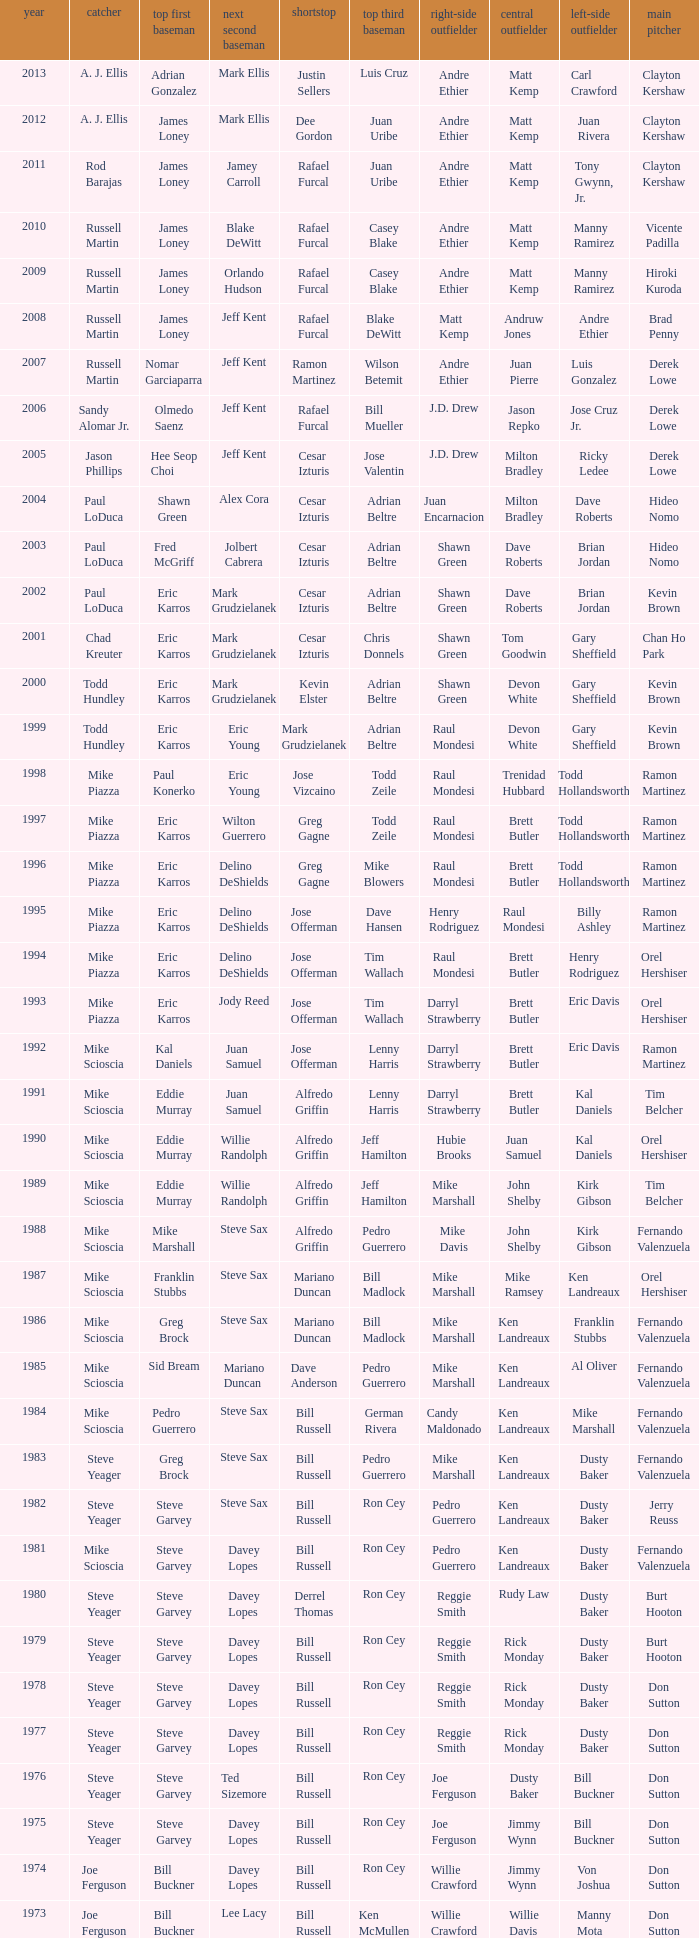Who played 2nd base when nomar garciaparra was at 1st base? Jeff Kent. 